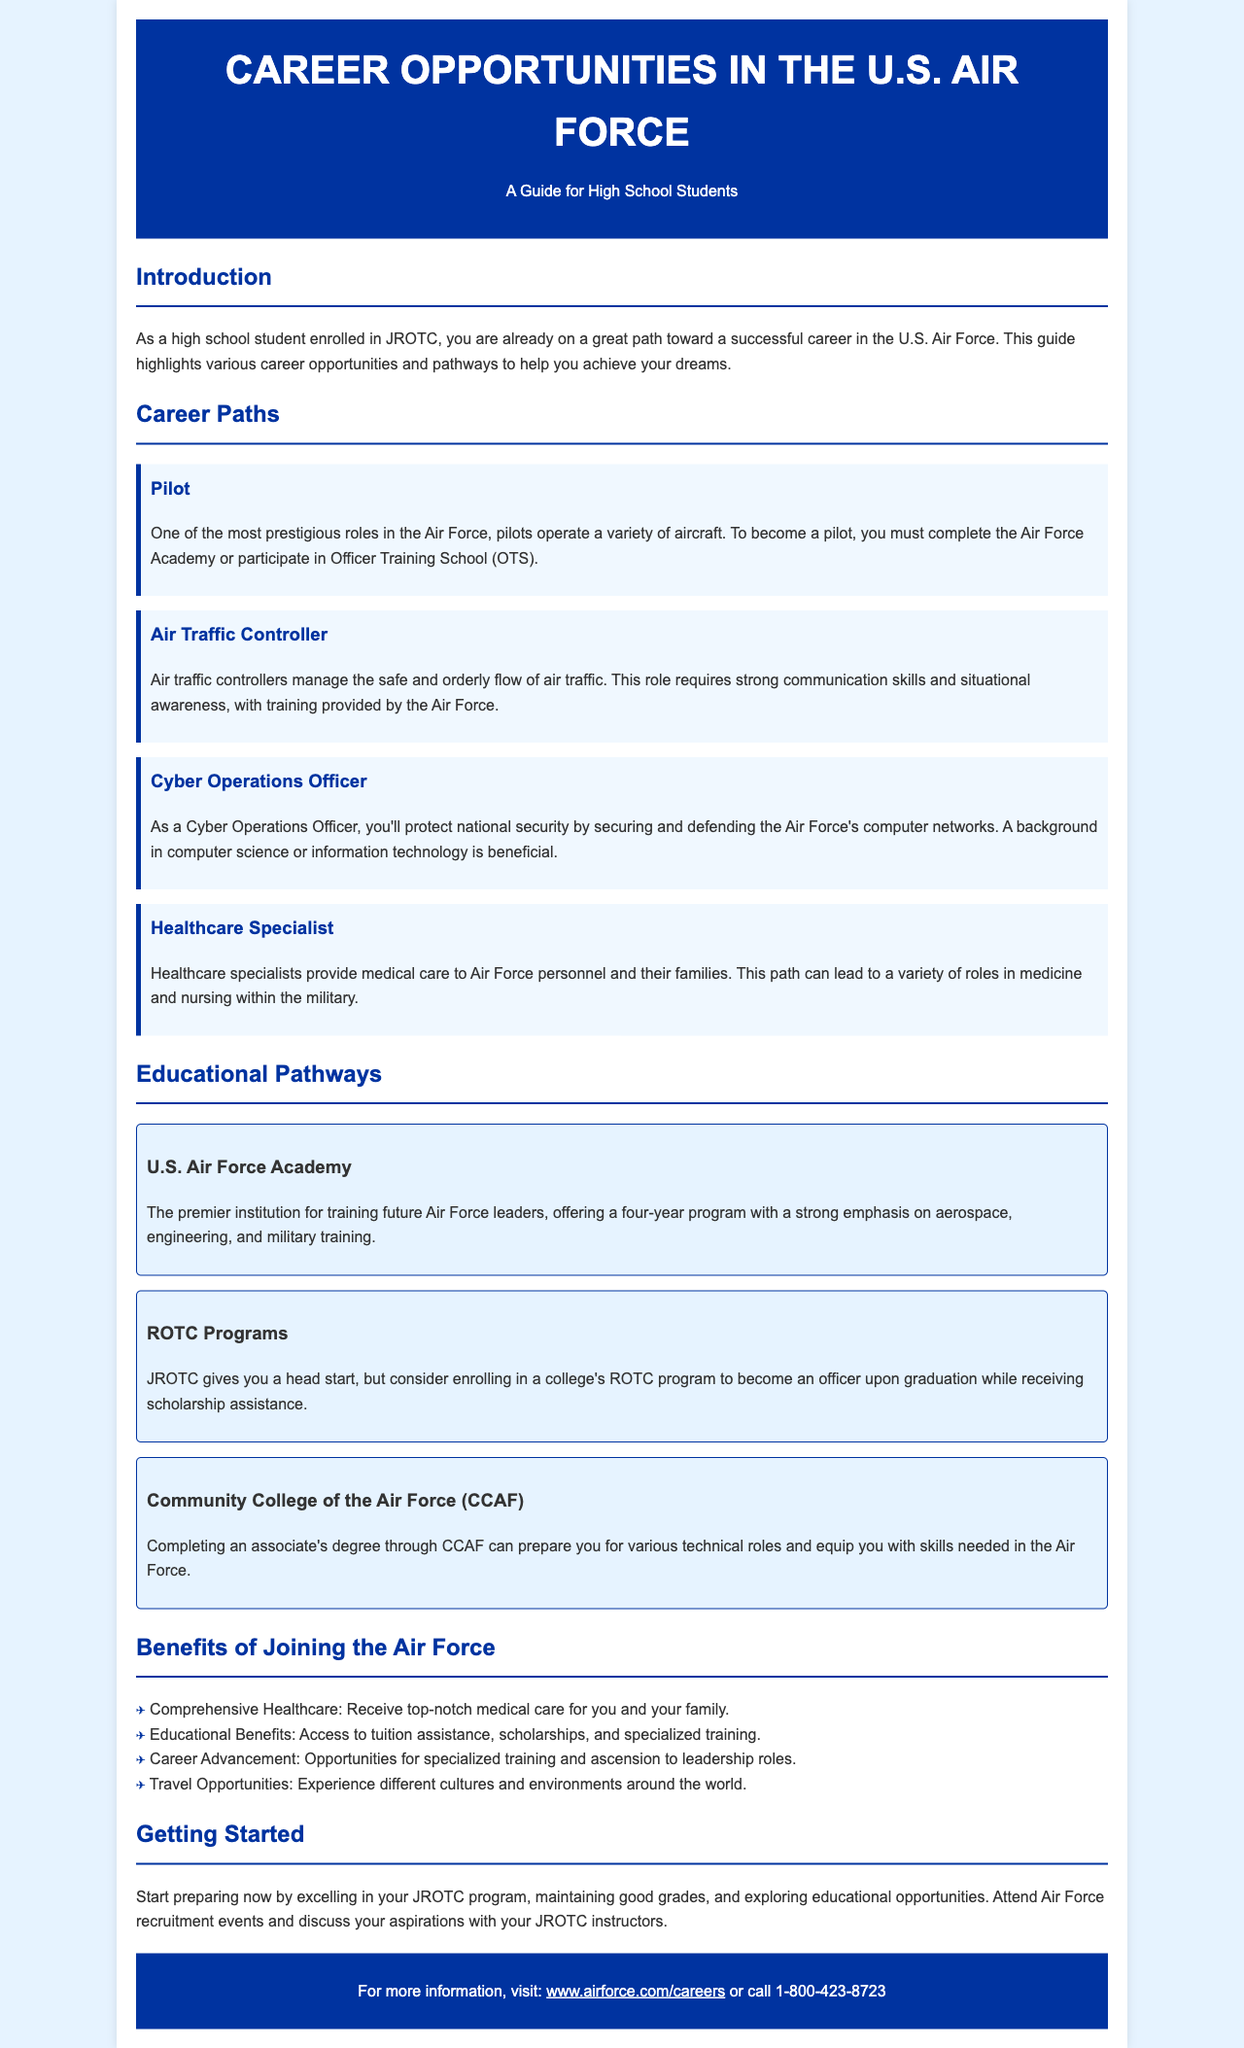What is the main audience for this guide? The guide is tailored for high school students, specifically those enrolled in JROTC.
Answer: high school students What is the role of a Pilot in the Air Force? A Pilot operates a variety of aircraft and must complete the Air Force Academy or participate in Officer Training School (OTS).
Answer: operates a variety of aircraft What do Air Traffic Controllers require in terms of skills? Air Traffic Controllers need strong communication skills and situational awareness.
Answer: strong communication skills and situational awareness What educational institution is described as the premier training center? The U.S. Air Force Academy is described as the premier institution for training future Air Force leaders.
Answer: U.S. Air Force Academy Which program can help students receive scholarship assistance for becoming officers? College's ROTC programs can provide scholarship assistance upon graduation.
Answer: ROTC programs What kind of degree does the Community College of the Air Force (CCAF) offer? The CCAF offers an associate's degree that prepares students for various technical roles.
Answer: associate's degree One benefit of joining the Air Force is access to what type of benefits? Joining the Air Force provides educational benefits such as tuition assistance and scholarships.
Answer: educational benefits What should students do to start preparing for a career in the Air Force? Students should excel in their JROTC program and maintain good grades.
Answer: excel in JROTC and maintain good grades How can students find more information about Air Force careers? Students can visit the website www.airforce.com/careers or call a toll-free number.
Answer: www.airforce.com/careers or 1-800-423-8723 